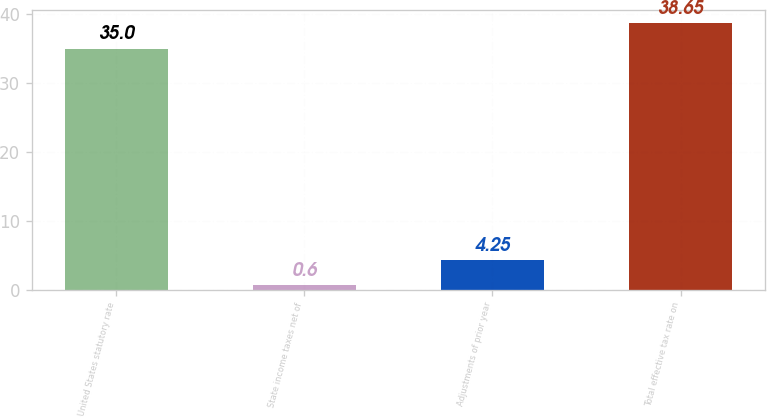Convert chart to OTSL. <chart><loc_0><loc_0><loc_500><loc_500><bar_chart><fcel>United States statutory rate<fcel>State income taxes net of<fcel>Adjustments of prior year<fcel>Total effective tax rate on<nl><fcel>35<fcel>0.6<fcel>4.25<fcel>38.65<nl></chart> 